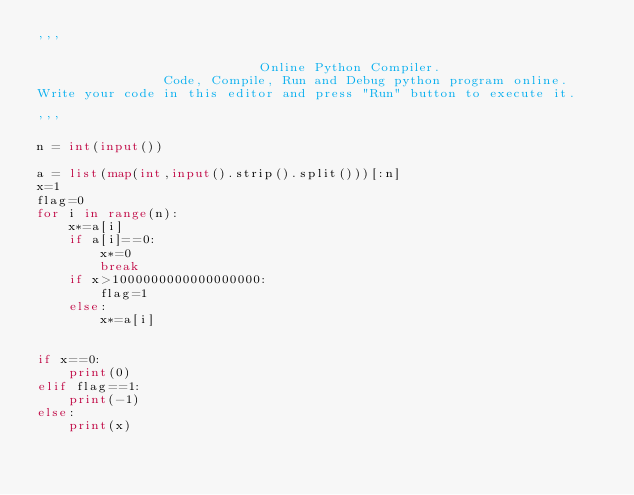Convert code to text. <code><loc_0><loc_0><loc_500><loc_500><_Python_>'''

                            Online Python Compiler.
                Code, Compile, Run and Debug python program online.
Write your code in this editor and press "Run" button to execute it.

'''

n = int(input()) 
  
a = list(map(int,input().strip().split()))[:n] 
x=1
flag=0
for i in range(n):
    x*=a[i]
    if a[i]==0:
        x*=0
        break
    if x>1000000000000000000:
        flag=1
    else:
        x*=a[i]
        

if x==0:
    print(0)
elif flag==1:
    print(-1)
else:
    print(x)
    
</code> 